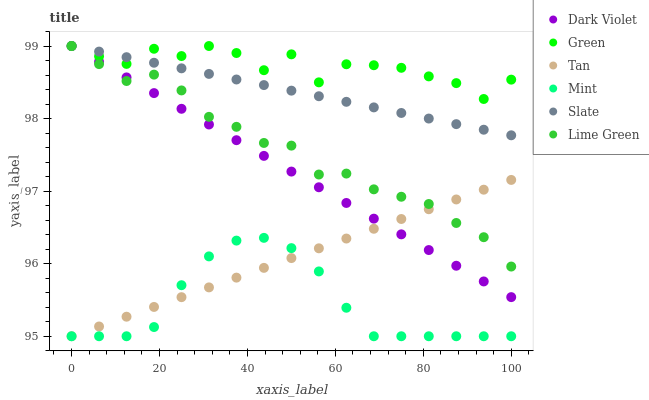Does Mint have the minimum area under the curve?
Answer yes or no. Yes. Does Green have the maximum area under the curve?
Answer yes or no. Yes. Does Slate have the minimum area under the curve?
Answer yes or no. No. Does Slate have the maximum area under the curve?
Answer yes or no. No. Is Slate the smoothest?
Answer yes or no. Yes. Is Green the roughest?
Answer yes or no. Yes. Is Dark Violet the smoothest?
Answer yes or no. No. Is Dark Violet the roughest?
Answer yes or no. No. Does Mint have the lowest value?
Answer yes or no. Yes. Does Slate have the lowest value?
Answer yes or no. No. Does Lime Green have the highest value?
Answer yes or no. Yes. Does Tan have the highest value?
Answer yes or no. No. Is Mint less than Green?
Answer yes or no. Yes. Is Green greater than Mint?
Answer yes or no. Yes. Does Dark Violet intersect Slate?
Answer yes or no. Yes. Is Dark Violet less than Slate?
Answer yes or no. No. Is Dark Violet greater than Slate?
Answer yes or no. No. Does Mint intersect Green?
Answer yes or no. No. 